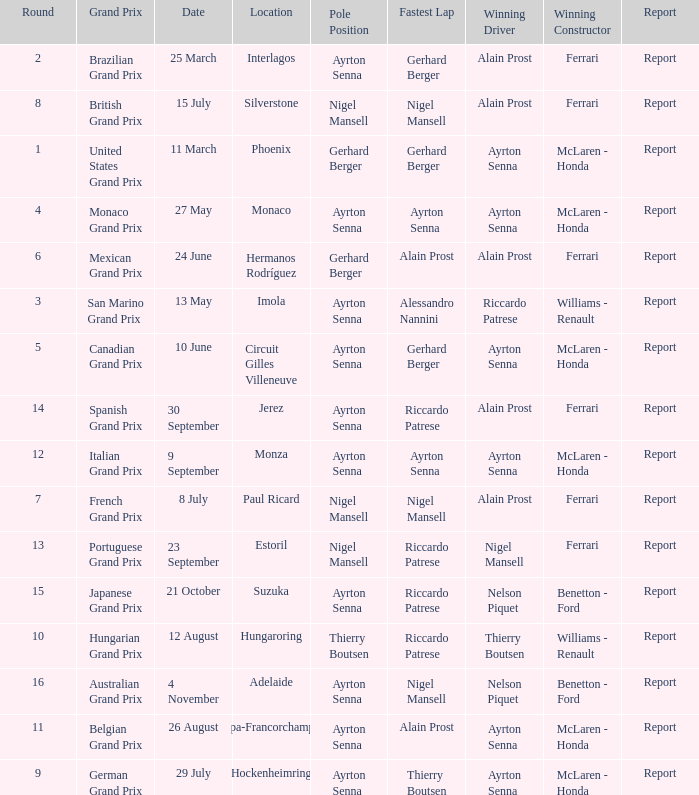What was the constructor when riccardo patrese was the winning driver? Williams - Renault. 